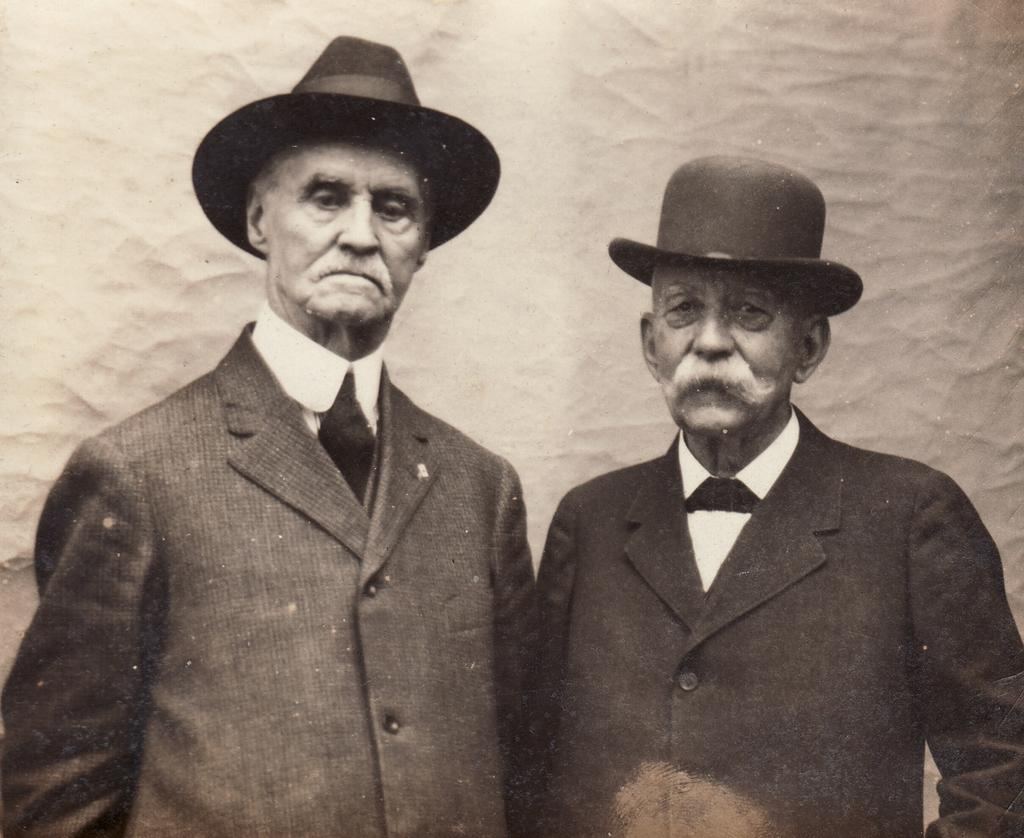What is the color scheme of the image? The image is black and white. How many people are in the picture? There are two men in the picture. What are the men doing in the image? The men are standing. What are the men wearing in the image? The men are wearing suits and hats. What can be seen in the background of the image? The background is white. What type of nut is being used to stir the stew in the image? There is no nut or stew present in the image; it features two men standing in black and white attire with a white background. 